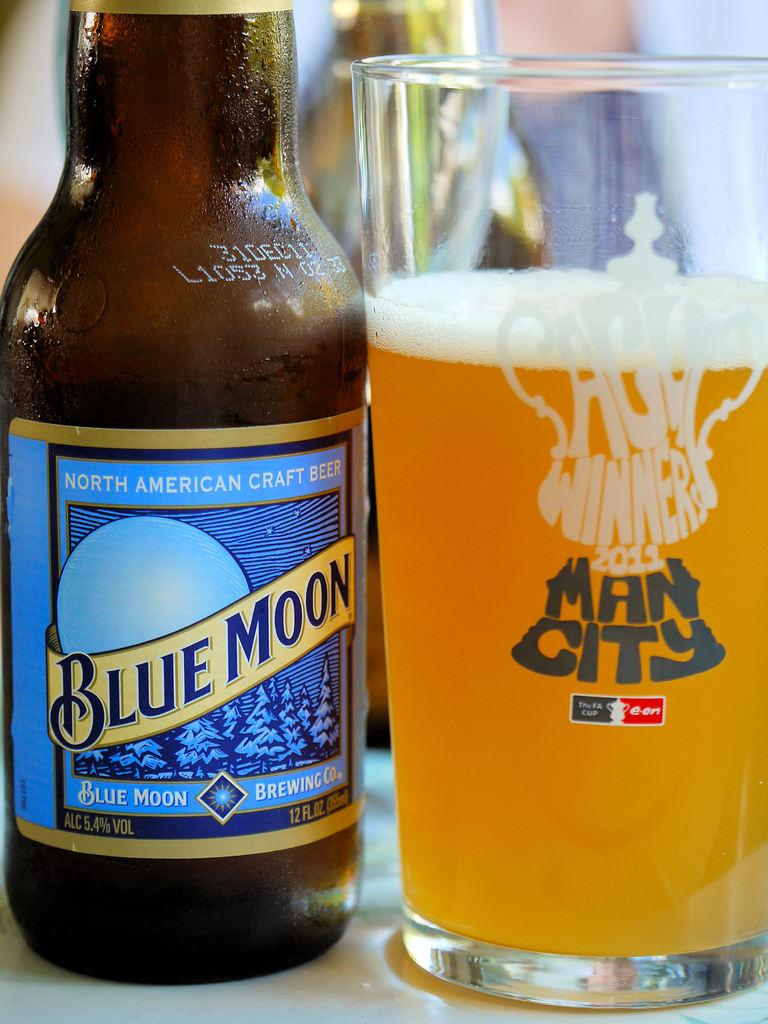Provide a one-sentence caption for the provided image. Bottle of blue moon north american craft beer with a man city glass beside it. 